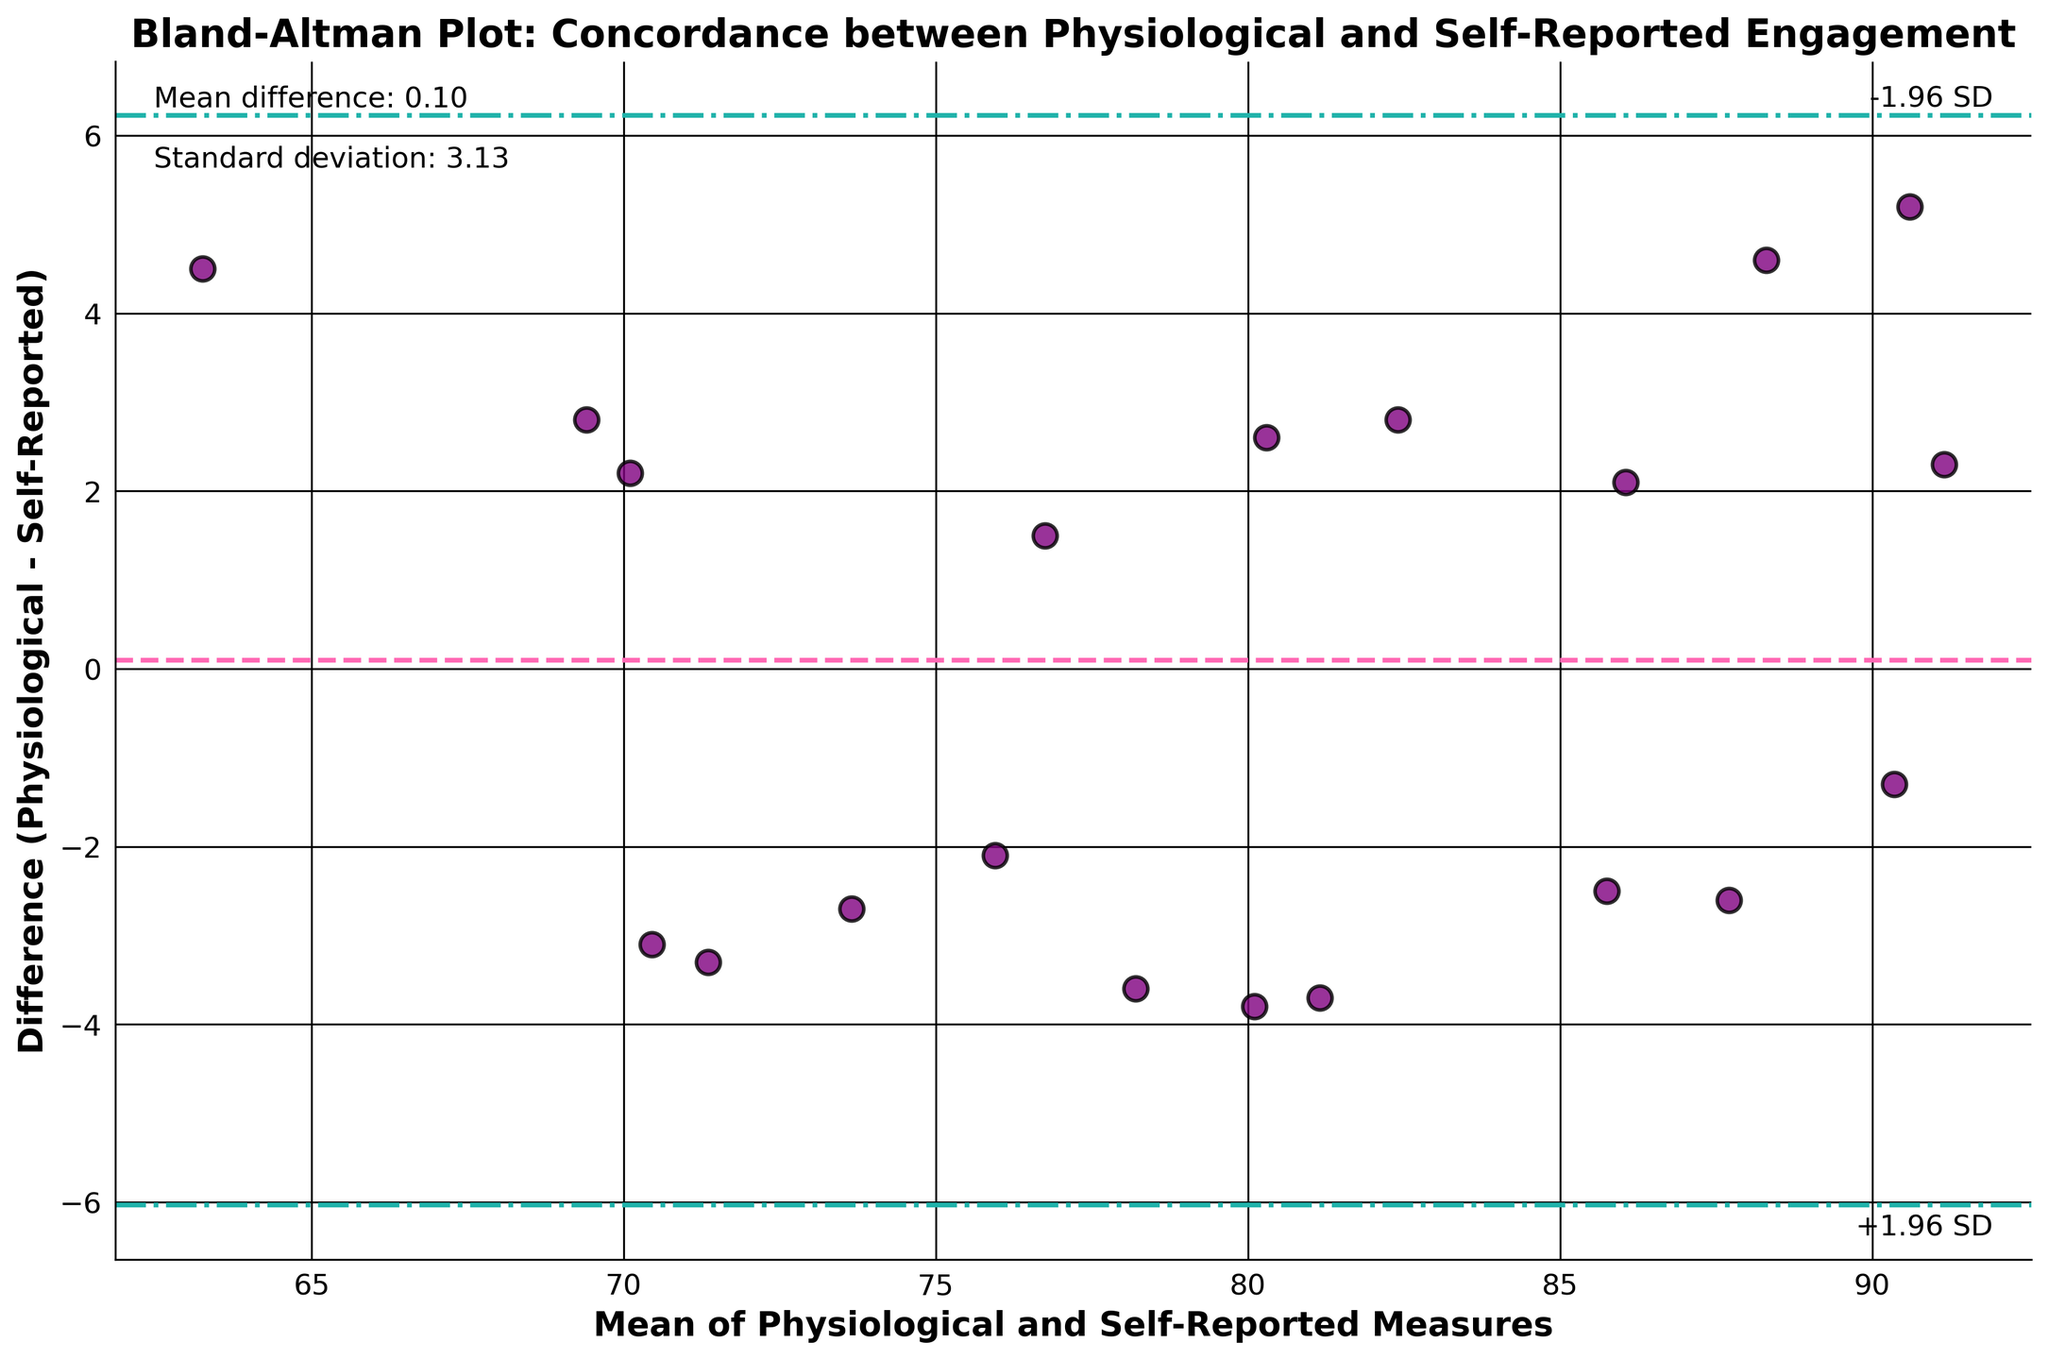What is the main title of the plot? The title is usually found at the top of the plot, summarizing the purpose or the main focus of the figure. From the example data and code, it is: "Bland-Altman Plot: Concordance between Physiological and Self-Reported Engagement."
Answer: Bland-Altman Plot: Concordance between Physiological and Self-Reported Engagement How many data points are plotted in the scatter plot? Each data point represents a subject, plotted using the mean of two measurements on the x-axis and their difference on the y-axis. By counting the subjects in the data, we can see there are 20 individuals.
Answer: 20 What do the horizontal dashed lines represent in the plot? Horizontal dashed lines typically indicate statistical boundaries in a Bland-Altman plot. The middle dashed line represents the mean difference, while the upper and lower dashed lines represent the mean difference ± 1.96 times the standard deviation. These boundaries indicate the range in which 95% of the differences are expected to fall.
Answer: Mean difference and ± 1.96 SD boundaries What is the mean difference between physiological and self-reported measures? The mean difference is the central horizontal line on the plot, often labelled or shown in the figure’s legend. This value is also computed and displayed in the figure text as per the given code.
Answer: 0.67 What is the standard deviation of the differences? The standard deviation of the differences is a measure of spread around the mean difference. It is displayed in the figure text as "Standard deviation" and is computed in the code.
Answer: 5.52 Which data point has the largest positive difference between physiological and self-reported engagement? To determine the largest positive difference, identify the highest point above the zero line on the y-axis. This refers to the highest difference value among the plotted points.
Answer: Olivia Which data point has the largest negative difference between physiological and self-reported engagement? To determine the largest negative difference, identify the lowest point below the zero line on the y-axis. This corresponds to the most negative difference value among the plotted points.
Answer: Grace What color are the data points in the scatter plot? The color of the data points is commonly described in the text or visual elements of the plot. In the provided code, it is specified that the data points are colored 'purple.'
Answer: Purple Are there any points falling outside the ±1.96 SD lines? To answer, inspect whether any data points lie beyond the lines that represent the mean difference plus and minus 1.96 times the standard deviation. This usually requires counting points outside these boundaries.
Answer: No How does the Bland-Altman plot help assess the agreement between physiological and self-reported engagement measures? The Bland-Altman plot shows the agreement by plotting the differences between two measures against their averages. The limits of agreement (mean ± 1.96 SD) help identify systematic bias and the variability in disparities between measures, highlighting outliers and consistency across subjects.
Answer: Shows agreement, identifies bias and variability 